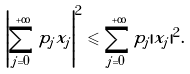<formula> <loc_0><loc_0><loc_500><loc_500>\left | \sum ^ { + \infty } _ { j = 0 } p _ { j } x _ { j } \right | ^ { 2 } \leqslant \sum ^ { + \infty } _ { j = 0 } p _ { j } | x _ { j } | ^ { 2 } .</formula> 